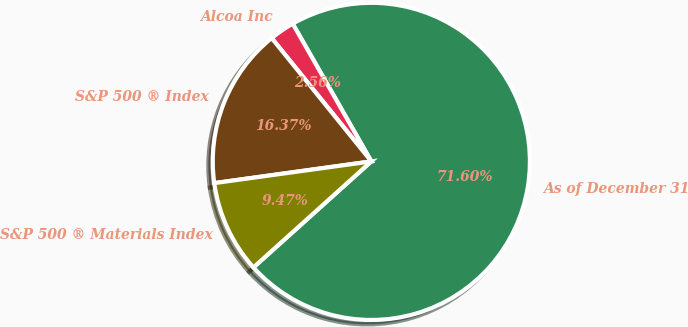<chart> <loc_0><loc_0><loc_500><loc_500><pie_chart><fcel>As of December 31<fcel>Alcoa Inc<fcel>S&P 500 ® Index<fcel>S&P 500 ® Materials Index<nl><fcel>71.6%<fcel>2.56%<fcel>16.37%<fcel>9.47%<nl></chart> 